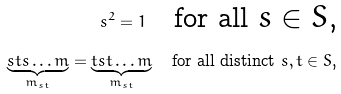Convert formula to latex. <formula><loc_0><loc_0><loc_500><loc_500>s ^ { 2 } = 1 \quad \text {for all $s \in S$,} \\ \underbrace { s t s \dots m } _ { m _ { s t } } = \underbrace { t s t \dots m } _ { m _ { s t } } \quad \text {for all distinct $s,t \in S$,}</formula> 